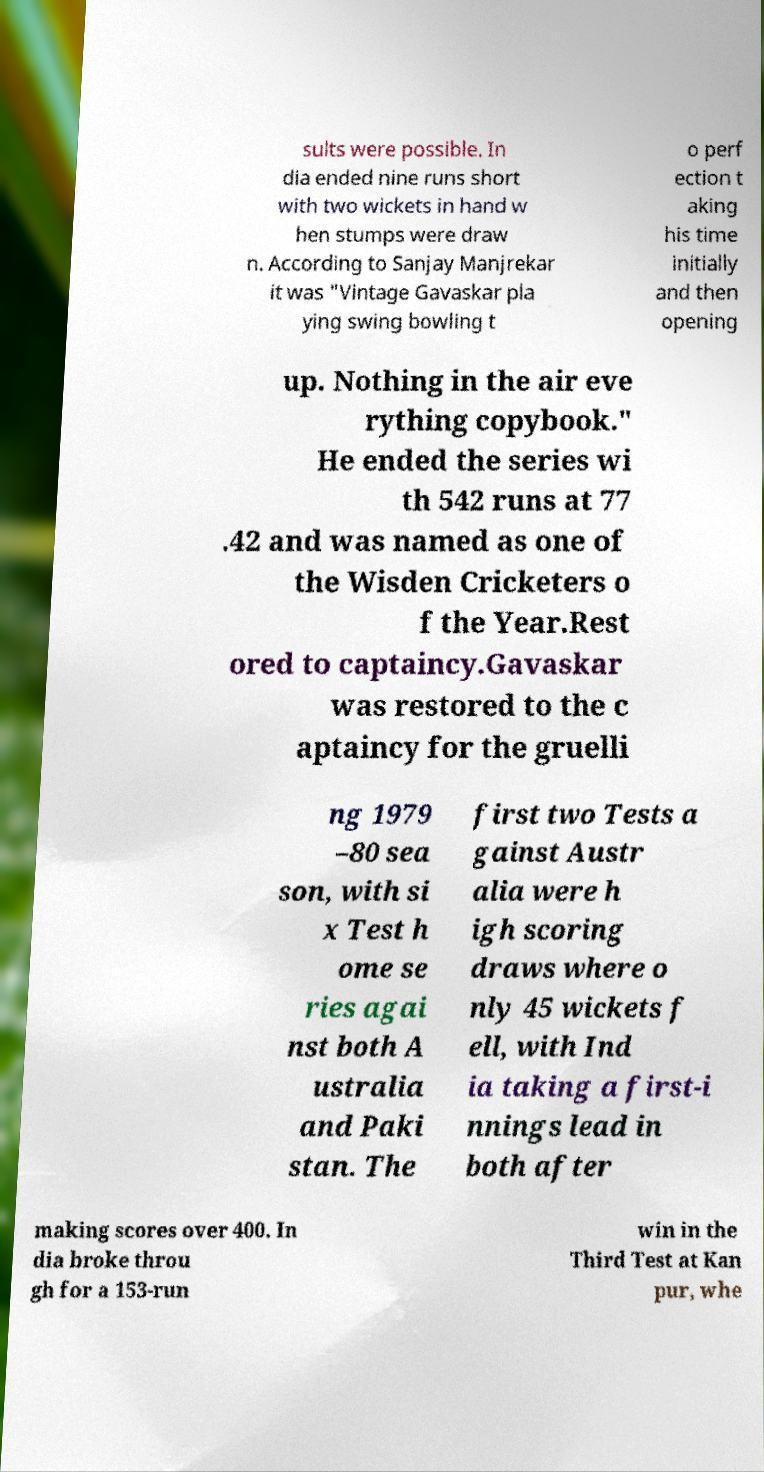Could you assist in decoding the text presented in this image and type it out clearly? sults were possible. In dia ended nine runs short with two wickets in hand w hen stumps were draw n. According to Sanjay Manjrekar it was "Vintage Gavaskar pla ying swing bowling t o perf ection t aking his time initially and then opening up. Nothing in the air eve rything copybook." He ended the series wi th 542 runs at 77 .42 and was named as one of the Wisden Cricketers o f the Year.Rest ored to captaincy.Gavaskar was restored to the c aptaincy for the gruelli ng 1979 –80 sea son, with si x Test h ome se ries agai nst both A ustralia and Paki stan. The first two Tests a gainst Austr alia were h igh scoring draws where o nly 45 wickets f ell, with Ind ia taking a first-i nnings lead in both after making scores over 400. In dia broke throu gh for a 153-run win in the Third Test at Kan pur, whe 